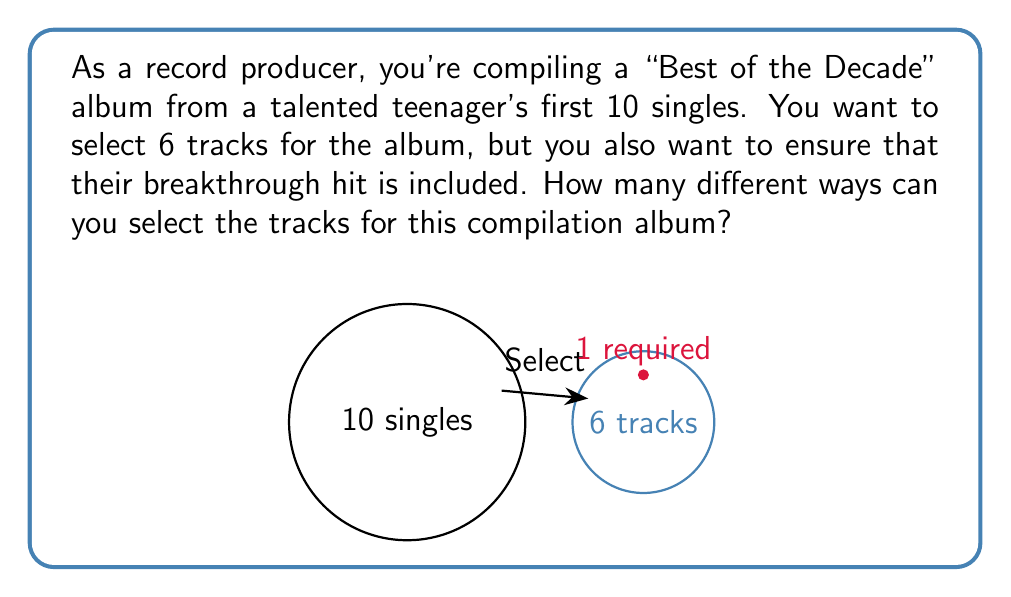Can you solve this math problem? Let's approach this step-by-step:

1) We have 10 singles in total, and we need to select 6 tracks.

2) One track (the breakthrough hit) is required to be in the album. This means we actually only need to choose 5 more tracks from the remaining 9 singles.

3) This is a combination problem. We're selecting 5 items from 9, where the order doesn't matter.

4) The formula for combinations is:

   $$C(n,r) = \frac{n!}{r!(n-r)!}$$

   where $n$ is the total number of items to choose from, and $r$ is the number of items being chosen.

5) In this case, $n = 9$ and $r = 5$. Let's substitute these values:

   $$C(9,5) = \frac{9!}{5!(9-5)!} = \frac{9!}{5!4!}$$

6) Expanding this:

   $$\frac{9 \times 8 \times 7 \times 6 \times 5!}{5! \times 4 \times 3 \times 2 \times 1}$$

7) The 5! cancels out in the numerator and denominator:

   $$\frac{9 \times 8 \times 7 \times 6}{4 \times 3 \times 2 \times 1} = \frac{3024}{24} = 126$$

Therefore, there are 126 different ways to select the tracks for the compilation album.
Answer: 126 